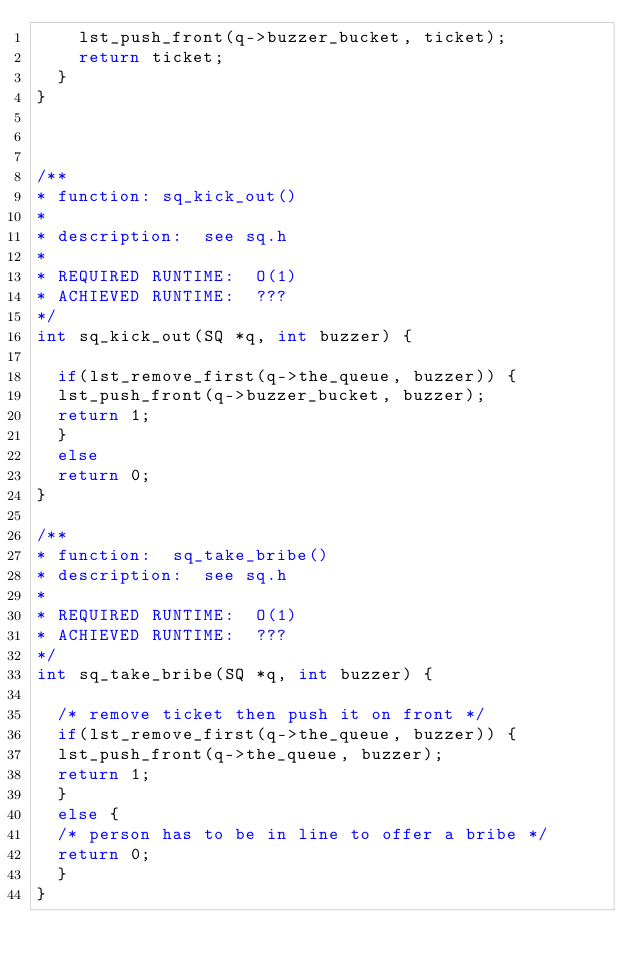Convert code to text. <code><loc_0><loc_0><loc_500><loc_500><_C_>	  lst_push_front(q->buzzer_bucket, ticket);
	  return ticket;
	}
} 



/**
* function: sq_kick_out()
*
* description:  see sq.h
*
* REQUIRED RUNTIME:  O(1)
* ACHIEVED RUNTIME:  ???
*/
int sq_kick_out(SQ *q, int buzzer) {

  if(lst_remove_first(q->the_queue, buzzer)) {
	lst_push_front(q->buzzer_bucket, buzzer);
	return 1;
  }
  else
	return 0;
}

/**
* function:  sq_take_bribe()
* description:  see sq.h
*
* REQUIRED RUNTIME:  O(1)
* ACHIEVED RUNTIME:  ???
*/
int sq_take_bribe(SQ *q, int buzzer) {

  /* remove ticket then push it on front */
  if(lst_remove_first(q->the_queue, buzzer)) {
	lst_push_front(q->the_queue, buzzer);
	return 1;
  }
  else {
	/* person has to be in line to offer a bribe */
	return 0;
  }
}





</code> 